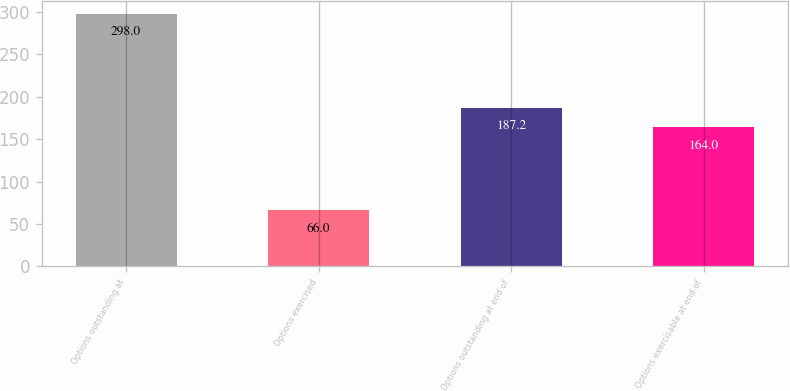<chart> <loc_0><loc_0><loc_500><loc_500><bar_chart><fcel>Options outstanding at<fcel>Options exercised<fcel>Options outstanding at end of<fcel>Options exercisable at end of<nl><fcel>298<fcel>66<fcel>187.2<fcel>164<nl></chart> 